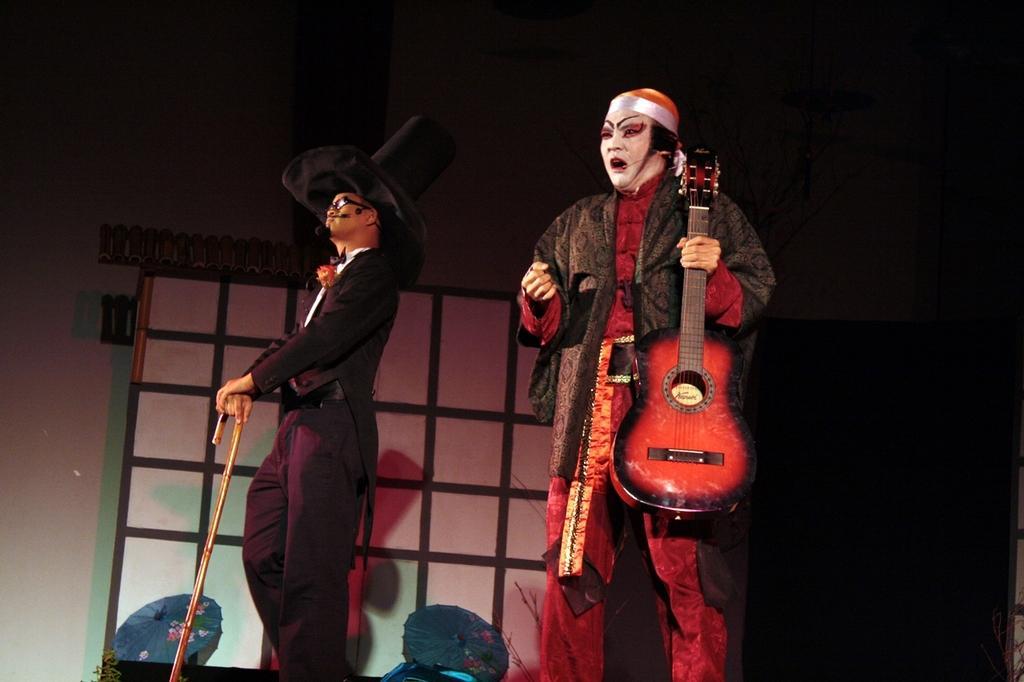Please provide a concise description of this image. The person wearing red dress is holding a guitar in his hand and the person wearing black dress is holding a stick in his hand. 